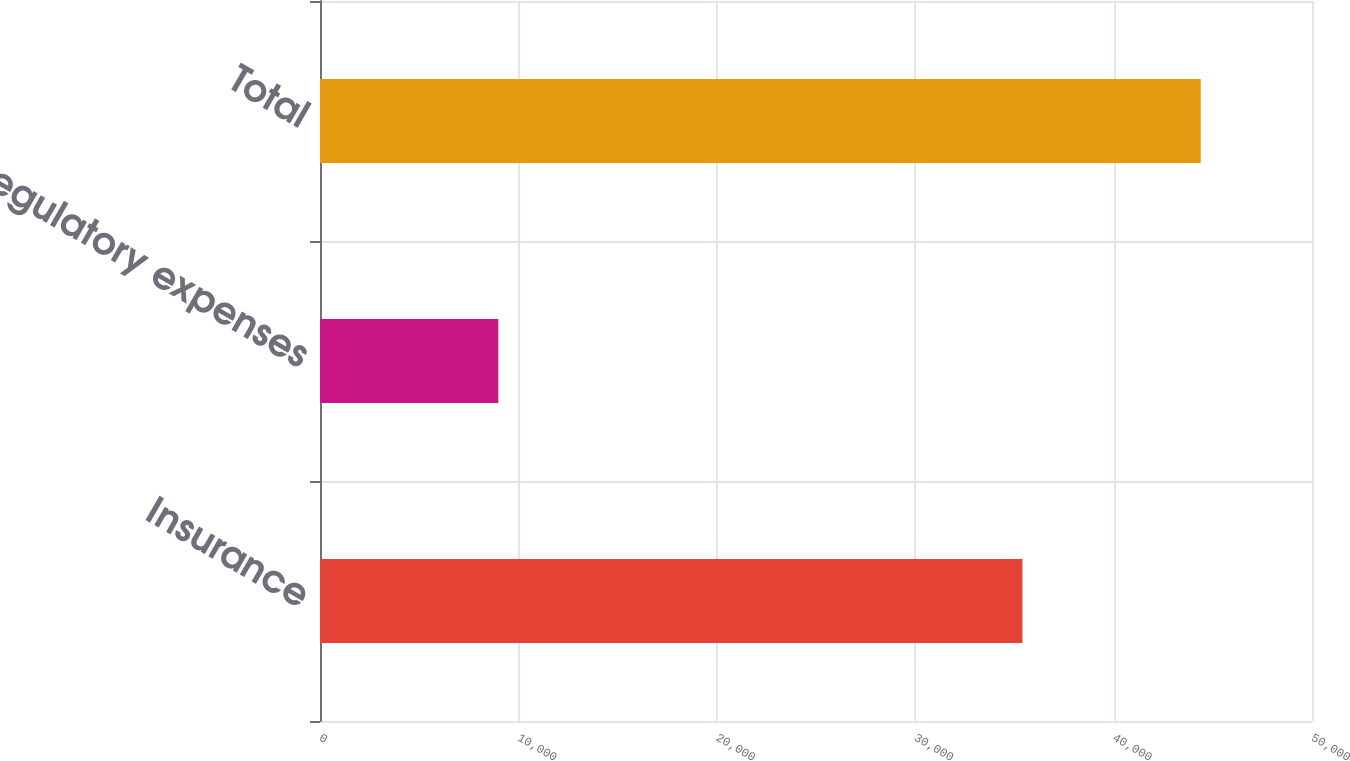<chart> <loc_0><loc_0><loc_500><loc_500><bar_chart><fcel>Insurance<fcel>Regulatory expenses<fcel>Total<nl><fcel>35406<fcel>8987<fcel>44393<nl></chart> 